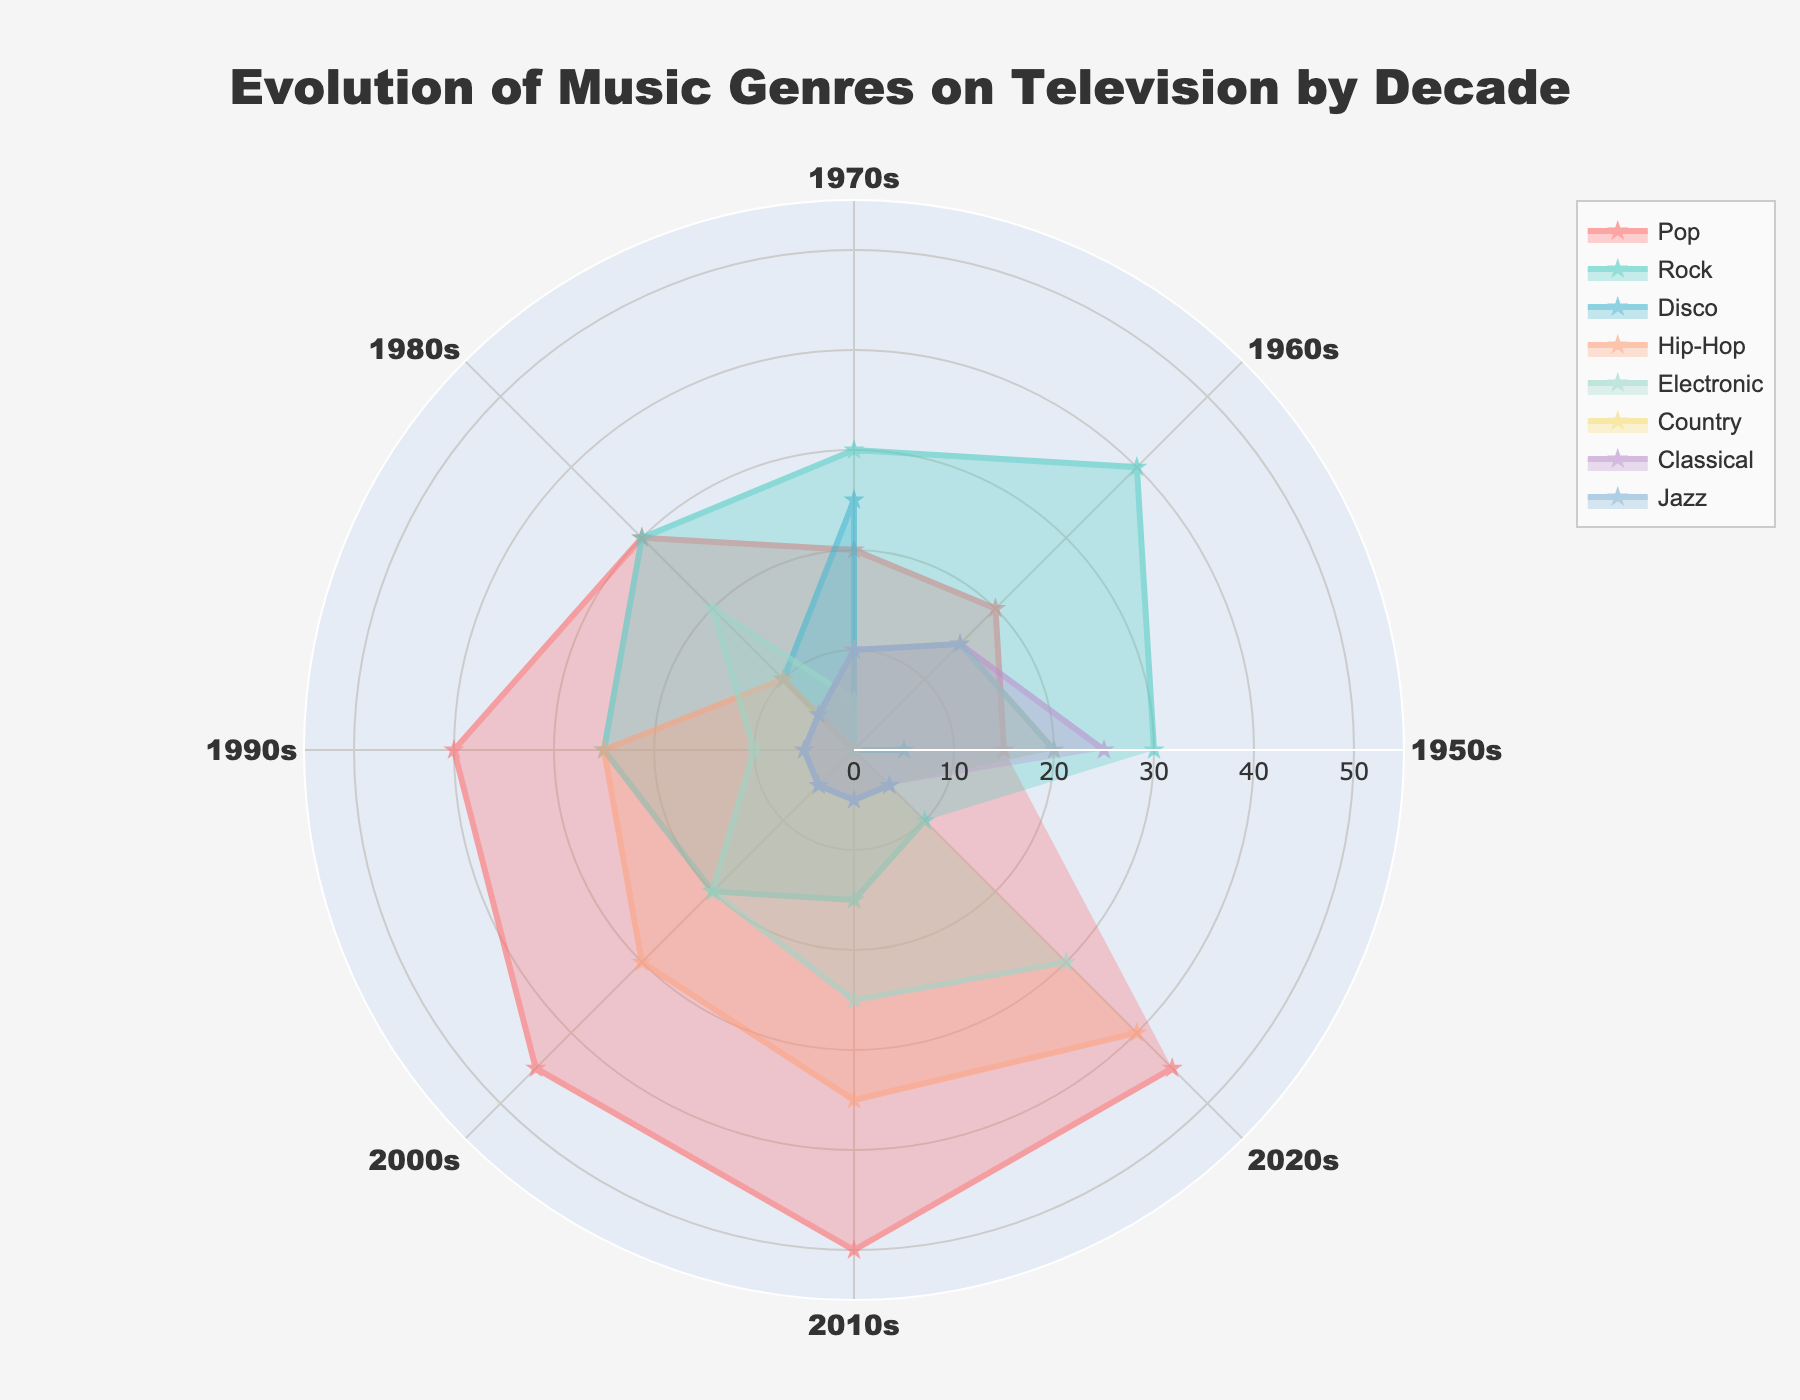What's the title of the chart? The title of the chart is prominently displayed at the top of the figure. By reading what is written there, we can determine the title.
Answer: Evolution of Music Genres on Television by Decade How does the popularity of Hip-Hop in the 2020s compare to the 1980s? To compare, we look at the values for Hip-Hop in both the 2020s and the 1980s on the radar chart. Hip-Hop's value in the 2020s is higher than in the 1980s.
Answer: Higher Which genre appeared (had non-zero value) on television for the first time in the 1980s? To identify this, we scan through the genres listed for the 1980s and compare them to previous decades. Hip-Hop, for example, has non-zero value starting from the 1980s while it was zero before.
Answer: Hip-Hop Which decade saw the highest popularity of Pop music? We examine the radial points for Pop music across all decades. The highest value appears in the 2010s.
Answer: 2010s In which decade did Disco first appear on television? By scanning the values for Disco, we note that the first non-zero value appears in the 1970s.
Answer: 1970s Which genre had a steady increase in popularity from the 1980s to the 2020s? Observing each genre's trend line from the 1980s to 2020s, we notice Hip-Hop's values consistently increasing from 10 to 40 over these decades.
Answer: Hip-Hop For the 1950s, what genre had the second highest value? Looking at the values for the 1950s, we see that Rock has the highest (30), and Classical is the second highest with a value of 25.
Answer: Classical 